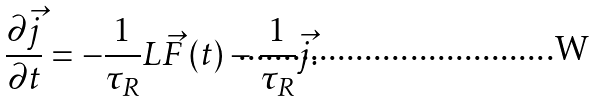<formula> <loc_0><loc_0><loc_500><loc_500>\frac { \partial \vec { j } } { \partial t } = - \frac { 1 } { \tau _ { R } } L \vec { F } \left ( t \right ) - \frac { 1 } { \tau _ { R } } \vec { j } .</formula> 